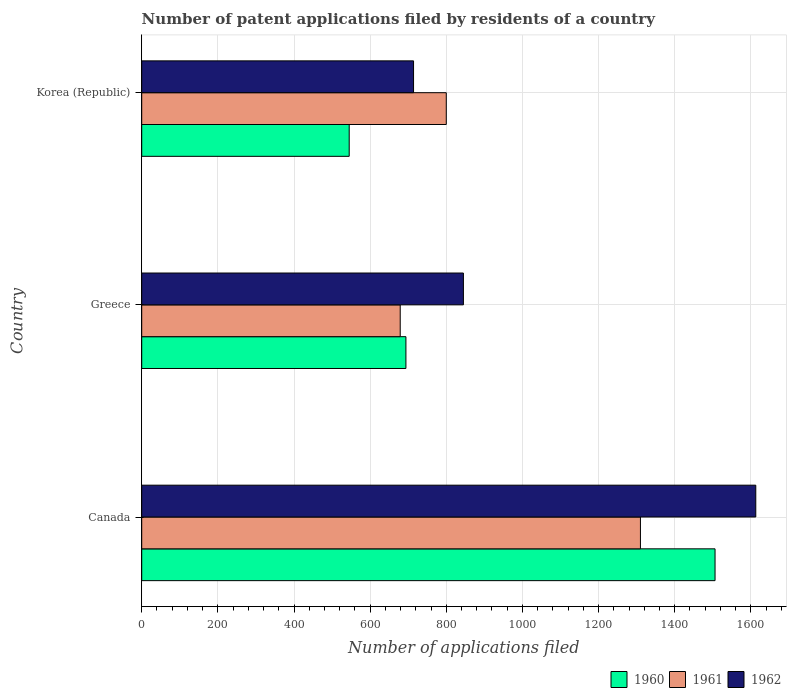How many different coloured bars are there?
Your answer should be compact. 3. In how many cases, is the number of bars for a given country not equal to the number of legend labels?
Offer a very short reply. 0. What is the number of applications filed in 1961 in Greece?
Your answer should be compact. 679. Across all countries, what is the maximum number of applications filed in 1961?
Give a very brief answer. 1310. Across all countries, what is the minimum number of applications filed in 1960?
Give a very brief answer. 545. In which country was the number of applications filed in 1961 maximum?
Provide a succinct answer. Canada. In which country was the number of applications filed in 1961 minimum?
Offer a very short reply. Greece. What is the total number of applications filed in 1960 in the graph?
Make the answer very short. 2745. What is the difference between the number of applications filed in 1960 in Canada and that in Korea (Republic)?
Provide a short and direct response. 961. What is the difference between the number of applications filed in 1961 in Greece and the number of applications filed in 1962 in Korea (Republic)?
Offer a very short reply. -35. What is the average number of applications filed in 1960 per country?
Your response must be concise. 915. What is the difference between the number of applications filed in 1961 and number of applications filed in 1962 in Canada?
Your answer should be compact. -303. What is the ratio of the number of applications filed in 1960 in Canada to that in Korea (Republic)?
Your answer should be very brief. 2.76. Is the difference between the number of applications filed in 1961 in Canada and Korea (Republic) greater than the difference between the number of applications filed in 1962 in Canada and Korea (Republic)?
Ensure brevity in your answer.  No. What is the difference between the highest and the second highest number of applications filed in 1961?
Offer a very short reply. 510. What is the difference between the highest and the lowest number of applications filed in 1961?
Provide a succinct answer. 631. What does the 2nd bar from the top in Korea (Republic) represents?
Provide a short and direct response. 1961. What does the 1st bar from the bottom in Korea (Republic) represents?
Provide a short and direct response. 1960. How many countries are there in the graph?
Your answer should be compact. 3. Are the values on the major ticks of X-axis written in scientific E-notation?
Your response must be concise. No. How many legend labels are there?
Your response must be concise. 3. How are the legend labels stacked?
Offer a very short reply. Horizontal. What is the title of the graph?
Provide a succinct answer. Number of patent applications filed by residents of a country. What is the label or title of the X-axis?
Your answer should be compact. Number of applications filed. What is the Number of applications filed in 1960 in Canada?
Make the answer very short. 1506. What is the Number of applications filed of 1961 in Canada?
Keep it short and to the point. 1310. What is the Number of applications filed of 1962 in Canada?
Make the answer very short. 1613. What is the Number of applications filed in 1960 in Greece?
Your answer should be compact. 694. What is the Number of applications filed in 1961 in Greece?
Keep it short and to the point. 679. What is the Number of applications filed in 1962 in Greece?
Keep it short and to the point. 845. What is the Number of applications filed in 1960 in Korea (Republic)?
Offer a very short reply. 545. What is the Number of applications filed of 1961 in Korea (Republic)?
Keep it short and to the point. 800. What is the Number of applications filed in 1962 in Korea (Republic)?
Offer a terse response. 714. Across all countries, what is the maximum Number of applications filed in 1960?
Keep it short and to the point. 1506. Across all countries, what is the maximum Number of applications filed in 1961?
Ensure brevity in your answer.  1310. Across all countries, what is the maximum Number of applications filed in 1962?
Provide a short and direct response. 1613. Across all countries, what is the minimum Number of applications filed of 1960?
Provide a short and direct response. 545. Across all countries, what is the minimum Number of applications filed in 1961?
Your response must be concise. 679. Across all countries, what is the minimum Number of applications filed of 1962?
Offer a terse response. 714. What is the total Number of applications filed of 1960 in the graph?
Your answer should be compact. 2745. What is the total Number of applications filed of 1961 in the graph?
Keep it short and to the point. 2789. What is the total Number of applications filed in 1962 in the graph?
Offer a very short reply. 3172. What is the difference between the Number of applications filed of 1960 in Canada and that in Greece?
Give a very brief answer. 812. What is the difference between the Number of applications filed in 1961 in Canada and that in Greece?
Ensure brevity in your answer.  631. What is the difference between the Number of applications filed in 1962 in Canada and that in Greece?
Offer a terse response. 768. What is the difference between the Number of applications filed of 1960 in Canada and that in Korea (Republic)?
Make the answer very short. 961. What is the difference between the Number of applications filed of 1961 in Canada and that in Korea (Republic)?
Provide a short and direct response. 510. What is the difference between the Number of applications filed in 1962 in Canada and that in Korea (Republic)?
Offer a very short reply. 899. What is the difference between the Number of applications filed of 1960 in Greece and that in Korea (Republic)?
Provide a succinct answer. 149. What is the difference between the Number of applications filed in 1961 in Greece and that in Korea (Republic)?
Make the answer very short. -121. What is the difference between the Number of applications filed of 1962 in Greece and that in Korea (Republic)?
Offer a very short reply. 131. What is the difference between the Number of applications filed in 1960 in Canada and the Number of applications filed in 1961 in Greece?
Offer a very short reply. 827. What is the difference between the Number of applications filed in 1960 in Canada and the Number of applications filed in 1962 in Greece?
Provide a short and direct response. 661. What is the difference between the Number of applications filed of 1961 in Canada and the Number of applications filed of 1962 in Greece?
Give a very brief answer. 465. What is the difference between the Number of applications filed in 1960 in Canada and the Number of applications filed in 1961 in Korea (Republic)?
Your answer should be compact. 706. What is the difference between the Number of applications filed in 1960 in Canada and the Number of applications filed in 1962 in Korea (Republic)?
Offer a very short reply. 792. What is the difference between the Number of applications filed in 1961 in Canada and the Number of applications filed in 1962 in Korea (Republic)?
Offer a very short reply. 596. What is the difference between the Number of applications filed in 1960 in Greece and the Number of applications filed in 1961 in Korea (Republic)?
Ensure brevity in your answer.  -106. What is the difference between the Number of applications filed in 1960 in Greece and the Number of applications filed in 1962 in Korea (Republic)?
Provide a short and direct response. -20. What is the difference between the Number of applications filed of 1961 in Greece and the Number of applications filed of 1962 in Korea (Republic)?
Keep it short and to the point. -35. What is the average Number of applications filed of 1960 per country?
Make the answer very short. 915. What is the average Number of applications filed in 1961 per country?
Keep it short and to the point. 929.67. What is the average Number of applications filed in 1962 per country?
Offer a terse response. 1057.33. What is the difference between the Number of applications filed in 1960 and Number of applications filed in 1961 in Canada?
Make the answer very short. 196. What is the difference between the Number of applications filed in 1960 and Number of applications filed in 1962 in Canada?
Give a very brief answer. -107. What is the difference between the Number of applications filed in 1961 and Number of applications filed in 1962 in Canada?
Make the answer very short. -303. What is the difference between the Number of applications filed of 1960 and Number of applications filed of 1962 in Greece?
Keep it short and to the point. -151. What is the difference between the Number of applications filed in 1961 and Number of applications filed in 1962 in Greece?
Your answer should be compact. -166. What is the difference between the Number of applications filed of 1960 and Number of applications filed of 1961 in Korea (Republic)?
Offer a very short reply. -255. What is the difference between the Number of applications filed of 1960 and Number of applications filed of 1962 in Korea (Republic)?
Your response must be concise. -169. What is the difference between the Number of applications filed of 1961 and Number of applications filed of 1962 in Korea (Republic)?
Provide a succinct answer. 86. What is the ratio of the Number of applications filed in 1960 in Canada to that in Greece?
Provide a short and direct response. 2.17. What is the ratio of the Number of applications filed in 1961 in Canada to that in Greece?
Keep it short and to the point. 1.93. What is the ratio of the Number of applications filed in 1962 in Canada to that in Greece?
Ensure brevity in your answer.  1.91. What is the ratio of the Number of applications filed of 1960 in Canada to that in Korea (Republic)?
Provide a succinct answer. 2.76. What is the ratio of the Number of applications filed in 1961 in Canada to that in Korea (Republic)?
Offer a very short reply. 1.64. What is the ratio of the Number of applications filed in 1962 in Canada to that in Korea (Republic)?
Your answer should be compact. 2.26. What is the ratio of the Number of applications filed of 1960 in Greece to that in Korea (Republic)?
Ensure brevity in your answer.  1.27. What is the ratio of the Number of applications filed of 1961 in Greece to that in Korea (Republic)?
Your response must be concise. 0.85. What is the ratio of the Number of applications filed in 1962 in Greece to that in Korea (Republic)?
Provide a short and direct response. 1.18. What is the difference between the highest and the second highest Number of applications filed in 1960?
Your answer should be very brief. 812. What is the difference between the highest and the second highest Number of applications filed in 1961?
Your answer should be very brief. 510. What is the difference between the highest and the second highest Number of applications filed in 1962?
Your answer should be compact. 768. What is the difference between the highest and the lowest Number of applications filed in 1960?
Your answer should be compact. 961. What is the difference between the highest and the lowest Number of applications filed of 1961?
Offer a terse response. 631. What is the difference between the highest and the lowest Number of applications filed in 1962?
Provide a short and direct response. 899. 